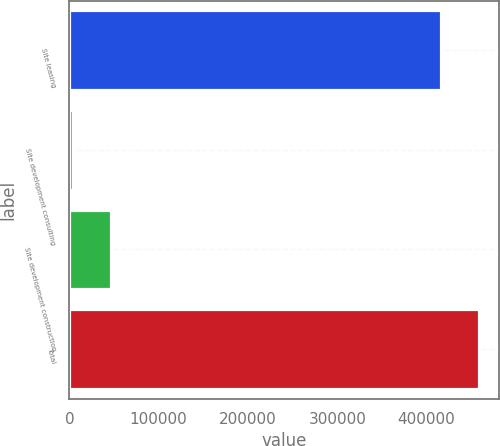<chart> <loc_0><loc_0><loc_500><loc_500><bar_chart><fcel>Site leasing<fcel>Site development consulting<fcel>Site development construction<fcel>Total<nl><fcel>416303<fcel>4235<fcel>46529.2<fcel>458597<nl></chart> 